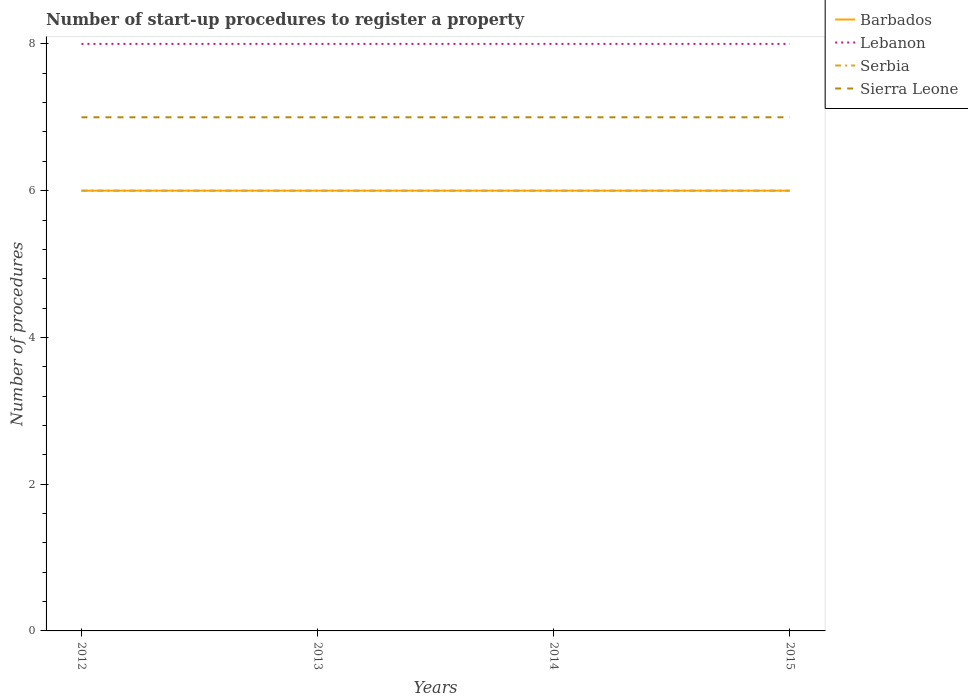Across all years, what is the maximum number of procedures required to register a property in Sierra Leone?
Your answer should be compact. 7. What is the total number of procedures required to register a property in Barbados in the graph?
Make the answer very short. 0. What is the difference between the highest and the lowest number of procedures required to register a property in Sierra Leone?
Give a very brief answer. 0. Is the number of procedures required to register a property in Lebanon strictly greater than the number of procedures required to register a property in Barbados over the years?
Offer a terse response. No. How many years are there in the graph?
Ensure brevity in your answer.  4. What is the difference between two consecutive major ticks on the Y-axis?
Keep it short and to the point. 2. How are the legend labels stacked?
Ensure brevity in your answer.  Vertical. What is the title of the graph?
Your answer should be very brief. Number of start-up procedures to register a property. Does "Bhutan" appear as one of the legend labels in the graph?
Your answer should be very brief. No. What is the label or title of the Y-axis?
Keep it short and to the point. Number of procedures. What is the Number of procedures of Lebanon in 2012?
Ensure brevity in your answer.  8. What is the Number of procedures of Serbia in 2012?
Ensure brevity in your answer.  6. What is the Number of procedures in Sierra Leone in 2012?
Your response must be concise. 7. What is the Number of procedures in Barbados in 2013?
Give a very brief answer. 6. What is the Number of procedures in Lebanon in 2013?
Provide a succinct answer. 8. What is the Number of procedures in Serbia in 2013?
Provide a short and direct response. 6. What is the Number of procedures of Sierra Leone in 2013?
Ensure brevity in your answer.  7. What is the Number of procedures of Lebanon in 2014?
Provide a short and direct response. 8. What is the Number of procedures of Serbia in 2014?
Make the answer very short. 6. What is the Number of procedures of Barbados in 2015?
Offer a terse response. 6. What is the Number of procedures in Lebanon in 2015?
Give a very brief answer. 8. Across all years, what is the maximum Number of procedures in Sierra Leone?
Provide a short and direct response. 7. Across all years, what is the minimum Number of procedures of Barbados?
Ensure brevity in your answer.  6. Across all years, what is the minimum Number of procedures in Lebanon?
Provide a succinct answer. 8. Across all years, what is the minimum Number of procedures in Serbia?
Keep it short and to the point. 6. What is the total Number of procedures in Barbados in the graph?
Make the answer very short. 24. What is the total Number of procedures in Lebanon in the graph?
Keep it short and to the point. 32. What is the total Number of procedures of Serbia in the graph?
Provide a succinct answer. 24. What is the total Number of procedures in Sierra Leone in the graph?
Your response must be concise. 28. What is the difference between the Number of procedures in Lebanon in 2012 and that in 2013?
Provide a short and direct response. 0. What is the difference between the Number of procedures of Serbia in 2012 and that in 2013?
Make the answer very short. 0. What is the difference between the Number of procedures in Barbados in 2012 and that in 2014?
Your answer should be compact. 0. What is the difference between the Number of procedures of Lebanon in 2012 and that in 2014?
Your answer should be very brief. 0. What is the difference between the Number of procedures of Barbados in 2012 and that in 2015?
Provide a short and direct response. 0. What is the difference between the Number of procedures of Barbados in 2013 and that in 2014?
Ensure brevity in your answer.  0. What is the difference between the Number of procedures in Lebanon in 2013 and that in 2014?
Offer a terse response. 0. What is the difference between the Number of procedures of Sierra Leone in 2013 and that in 2014?
Give a very brief answer. 0. What is the difference between the Number of procedures of Sierra Leone in 2014 and that in 2015?
Make the answer very short. 0. What is the difference between the Number of procedures of Barbados in 2012 and the Number of procedures of Lebanon in 2013?
Your answer should be compact. -2. What is the difference between the Number of procedures in Barbados in 2012 and the Number of procedures in Serbia in 2013?
Ensure brevity in your answer.  0. What is the difference between the Number of procedures of Barbados in 2012 and the Number of procedures of Sierra Leone in 2013?
Ensure brevity in your answer.  -1. What is the difference between the Number of procedures in Barbados in 2012 and the Number of procedures in Lebanon in 2014?
Provide a succinct answer. -2. What is the difference between the Number of procedures in Barbados in 2012 and the Number of procedures in Sierra Leone in 2014?
Offer a very short reply. -1. What is the difference between the Number of procedures of Lebanon in 2012 and the Number of procedures of Serbia in 2014?
Provide a short and direct response. 2. What is the difference between the Number of procedures in Barbados in 2012 and the Number of procedures in Lebanon in 2015?
Give a very brief answer. -2. What is the difference between the Number of procedures in Serbia in 2012 and the Number of procedures in Sierra Leone in 2015?
Your answer should be compact. -1. What is the difference between the Number of procedures of Barbados in 2013 and the Number of procedures of Serbia in 2014?
Keep it short and to the point. 0. What is the difference between the Number of procedures in Barbados in 2013 and the Number of procedures in Sierra Leone in 2014?
Your answer should be very brief. -1. What is the difference between the Number of procedures in Lebanon in 2013 and the Number of procedures in Sierra Leone in 2014?
Keep it short and to the point. 1. What is the difference between the Number of procedures of Serbia in 2013 and the Number of procedures of Sierra Leone in 2014?
Offer a terse response. -1. What is the difference between the Number of procedures in Barbados in 2013 and the Number of procedures in Sierra Leone in 2015?
Ensure brevity in your answer.  -1. What is the difference between the Number of procedures in Lebanon in 2013 and the Number of procedures in Serbia in 2015?
Give a very brief answer. 2. What is the difference between the Number of procedures of Lebanon in 2013 and the Number of procedures of Sierra Leone in 2015?
Provide a short and direct response. 1. What is the difference between the Number of procedures in Serbia in 2013 and the Number of procedures in Sierra Leone in 2015?
Keep it short and to the point. -1. What is the difference between the Number of procedures of Barbados in 2014 and the Number of procedures of Sierra Leone in 2015?
Make the answer very short. -1. What is the average Number of procedures of Barbados per year?
Your response must be concise. 6. What is the average Number of procedures of Serbia per year?
Keep it short and to the point. 6. In the year 2012, what is the difference between the Number of procedures in Barbados and Number of procedures in Lebanon?
Offer a terse response. -2. In the year 2012, what is the difference between the Number of procedures of Barbados and Number of procedures of Sierra Leone?
Keep it short and to the point. -1. In the year 2012, what is the difference between the Number of procedures in Serbia and Number of procedures in Sierra Leone?
Your response must be concise. -1. In the year 2013, what is the difference between the Number of procedures in Barbados and Number of procedures in Lebanon?
Offer a terse response. -2. In the year 2013, what is the difference between the Number of procedures of Barbados and Number of procedures of Serbia?
Ensure brevity in your answer.  0. In the year 2013, what is the difference between the Number of procedures of Lebanon and Number of procedures of Serbia?
Keep it short and to the point. 2. In the year 2013, what is the difference between the Number of procedures of Lebanon and Number of procedures of Sierra Leone?
Give a very brief answer. 1. In the year 2014, what is the difference between the Number of procedures in Barbados and Number of procedures in Serbia?
Offer a terse response. 0. In the year 2014, what is the difference between the Number of procedures of Barbados and Number of procedures of Sierra Leone?
Provide a short and direct response. -1. In the year 2014, what is the difference between the Number of procedures of Lebanon and Number of procedures of Serbia?
Your answer should be very brief. 2. In the year 2014, what is the difference between the Number of procedures in Lebanon and Number of procedures in Sierra Leone?
Your response must be concise. 1. In the year 2015, what is the difference between the Number of procedures of Barbados and Number of procedures of Serbia?
Your answer should be very brief. 0. In the year 2015, what is the difference between the Number of procedures in Barbados and Number of procedures in Sierra Leone?
Your answer should be compact. -1. In the year 2015, what is the difference between the Number of procedures in Lebanon and Number of procedures in Sierra Leone?
Your answer should be very brief. 1. What is the ratio of the Number of procedures of Barbados in 2012 to that in 2014?
Offer a very short reply. 1. What is the ratio of the Number of procedures of Serbia in 2012 to that in 2014?
Provide a short and direct response. 1. What is the ratio of the Number of procedures of Barbados in 2012 to that in 2015?
Offer a terse response. 1. What is the ratio of the Number of procedures of Lebanon in 2012 to that in 2015?
Ensure brevity in your answer.  1. What is the ratio of the Number of procedures of Serbia in 2012 to that in 2015?
Make the answer very short. 1. What is the ratio of the Number of procedures of Sierra Leone in 2012 to that in 2015?
Provide a succinct answer. 1. What is the ratio of the Number of procedures of Sierra Leone in 2013 to that in 2014?
Make the answer very short. 1. What is the ratio of the Number of procedures of Sierra Leone in 2013 to that in 2015?
Your answer should be very brief. 1. What is the ratio of the Number of procedures in Barbados in 2014 to that in 2015?
Keep it short and to the point. 1. What is the ratio of the Number of procedures in Serbia in 2014 to that in 2015?
Ensure brevity in your answer.  1. What is the ratio of the Number of procedures in Sierra Leone in 2014 to that in 2015?
Offer a terse response. 1. What is the difference between the highest and the second highest Number of procedures in Serbia?
Give a very brief answer. 0. What is the difference between the highest and the lowest Number of procedures of Barbados?
Your response must be concise. 0. What is the difference between the highest and the lowest Number of procedures in Lebanon?
Make the answer very short. 0. 